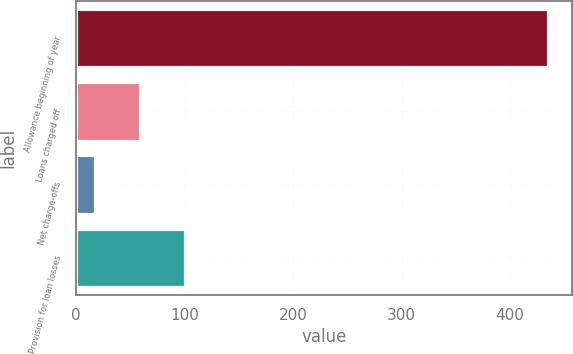<chart> <loc_0><loc_0><loc_500><loc_500><bar_chart><fcel>Allowance beginning of year<fcel>Loans charged off<fcel>Net charge-offs<fcel>Provision for loan losses<nl><fcel>435<fcel>58.8<fcel>17<fcel>100.6<nl></chart> 